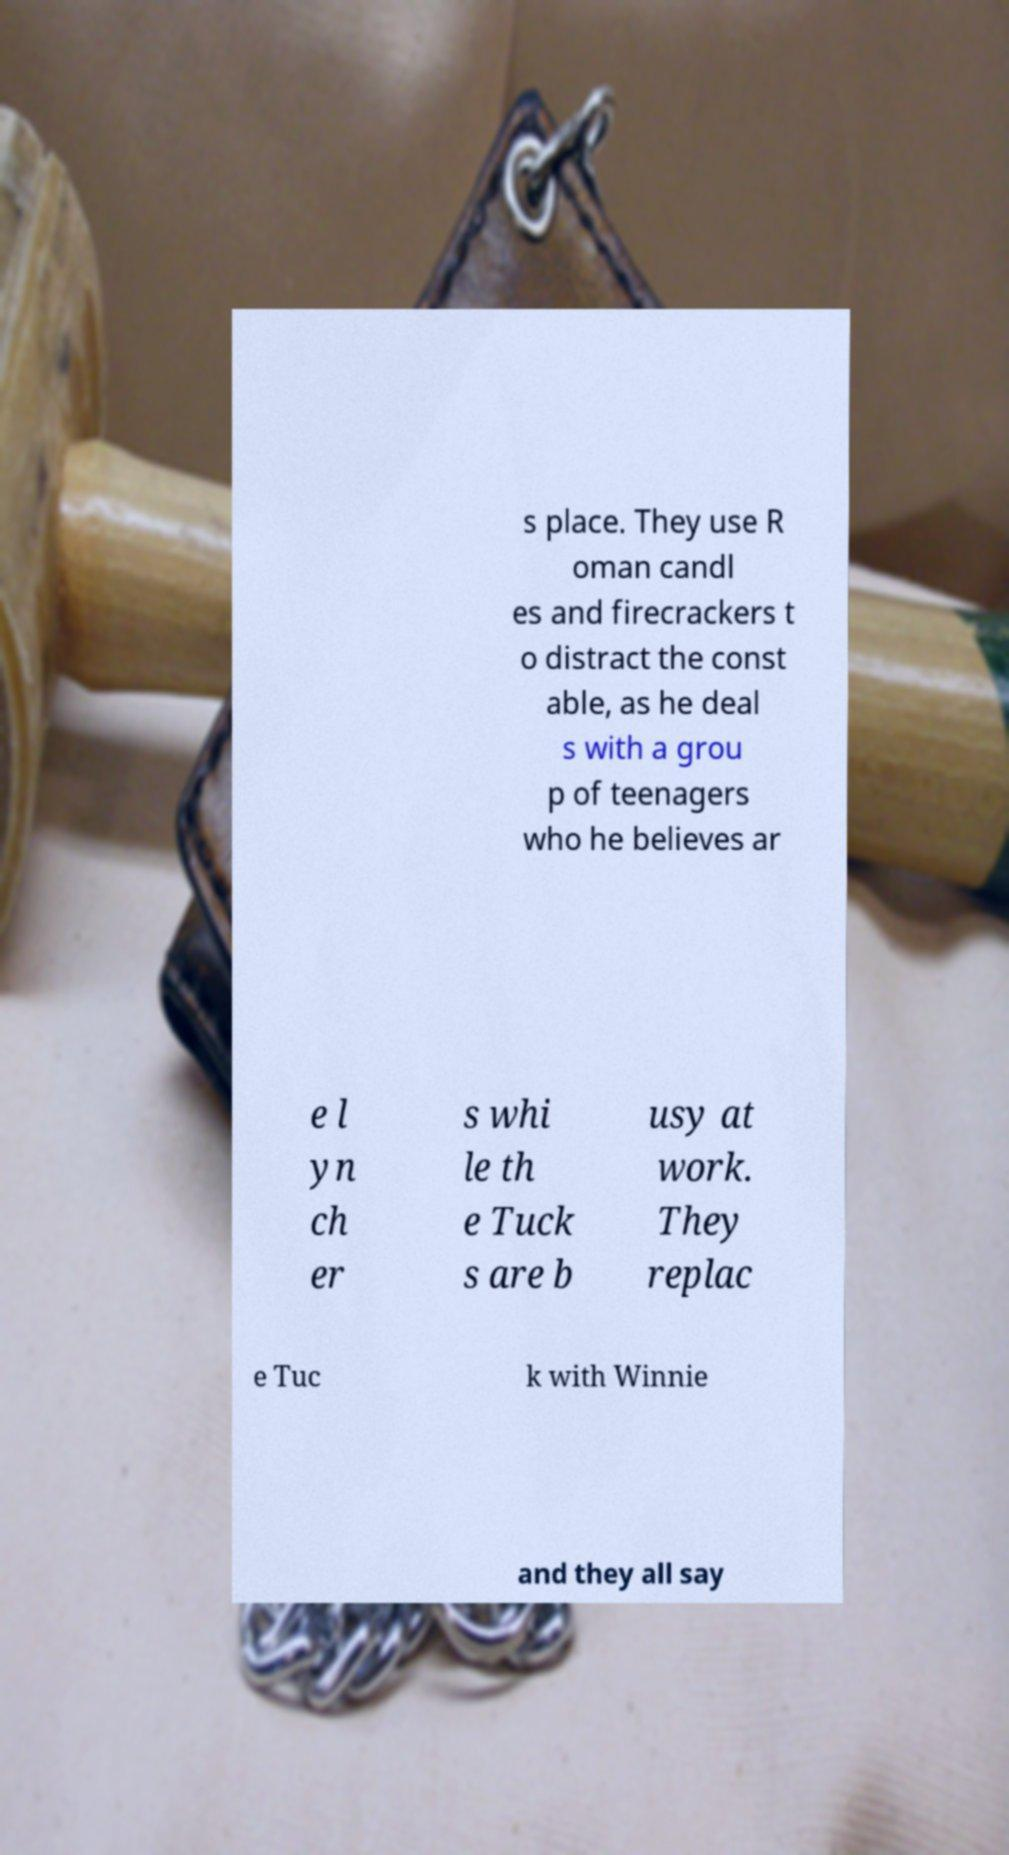What messages or text are displayed in this image? I need them in a readable, typed format. s place. They use R oman candl es and firecrackers t o distract the const able, as he deal s with a grou p of teenagers who he believes ar e l yn ch er s whi le th e Tuck s are b usy at work. They replac e Tuc k with Winnie and they all say 